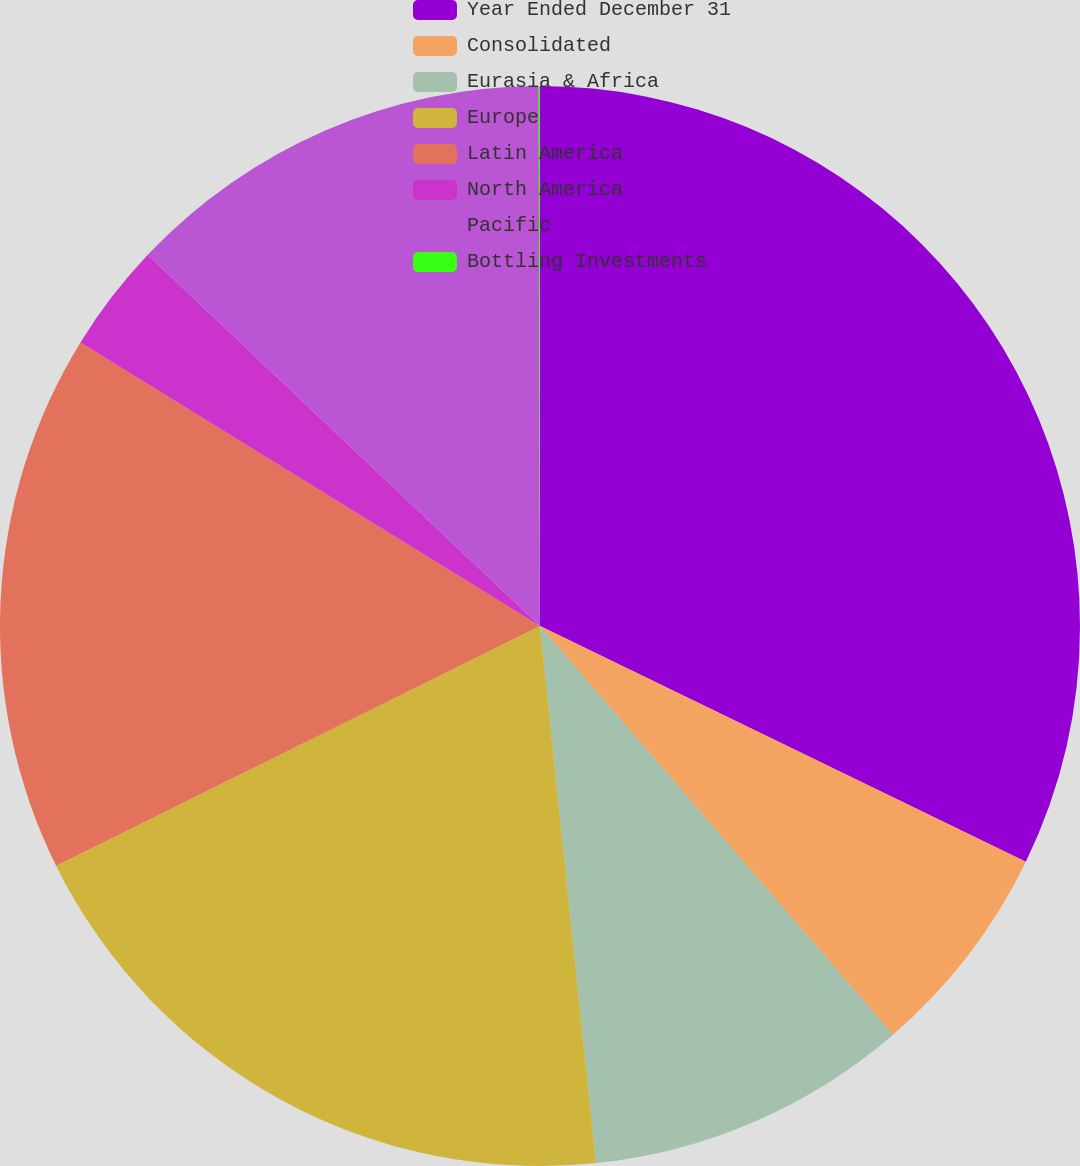Convert chart to OTSL. <chart><loc_0><loc_0><loc_500><loc_500><pie_chart><fcel>Year Ended December 31<fcel>Consolidated<fcel>Eurasia & Africa<fcel>Europe<fcel>Latin America<fcel>North America<fcel>Pacific<fcel>Bottling Investments<nl><fcel>32.19%<fcel>6.47%<fcel>9.69%<fcel>19.33%<fcel>16.12%<fcel>3.26%<fcel>12.9%<fcel>0.04%<nl></chart> 